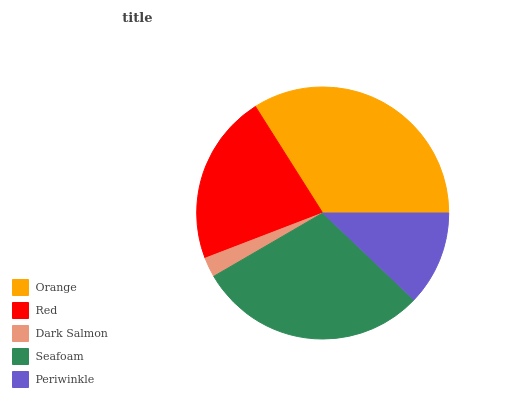Is Dark Salmon the minimum?
Answer yes or no. Yes. Is Orange the maximum?
Answer yes or no. Yes. Is Red the minimum?
Answer yes or no. No. Is Red the maximum?
Answer yes or no. No. Is Orange greater than Red?
Answer yes or no. Yes. Is Red less than Orange?
Answer yes or no. Yes. Is Red greater than Orange?
Answer yes or no. No. Is Orange less than Red?
Answer yes or no. No. Is Red the high median?
Answer yes or no. Yes. Is Red the low median?
Answer yes or no. Yes. Is Periwinkle the high median?
Answer yes or no. No. Is Orange the low median?
Answer yes or no. No. 